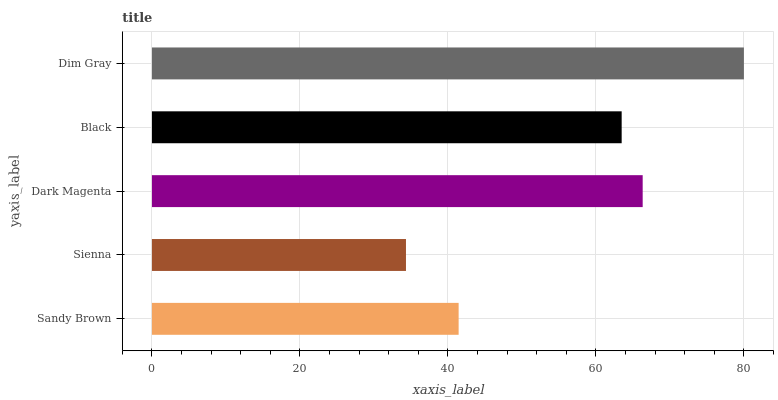Is Sienna the minimum?
Answer yes or no. Yes. Is Dim Gray the maximum?
Answer yes or no. Yes. Is Dark Magenta the minimum?
Answer yes or no. No. Is Dark Magenta the maximum?
Answer yes or no. No. Is Dark Magenta greater than Sienna?
Answer yes or no. Yes. Is Sienna less than Dark Magenta?
Answer yes or no. Yes. Is Sienna greater than Dark Magenta?
Answer yes or no. No. Is Dark Magenta less than Sienna?
Answer yes or no. No. Is Black the high median?
Answer yes or no. Yes. Is Black the low median?
Answer yes or no. Yes. Is Dim Gray the high median?
Answer yes or no. No. Is Sandy Brown the low median?
Answer yes or no. No. 